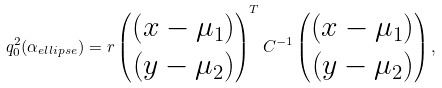Convert formula to latex. <formula><loc_0><loc_0><loc_500><loc_500>q _ { 0 } ^ { 2 } ( \alpha _ { e l l i p s e } ) = r \begin{pmatrix} \left ( x - \mu _ { 1 } \right ) \\ \left ( y - \mu _ { 2 } \right ) \end{pmatrix} ^ { T } C ^ { - 1 } \begin{pmatrix} \left ( x - \mu _ { 1 } \right ) \\ \left ( y - \mu _ { 2 } \right ) \end{pmatrix} ,</formula> 